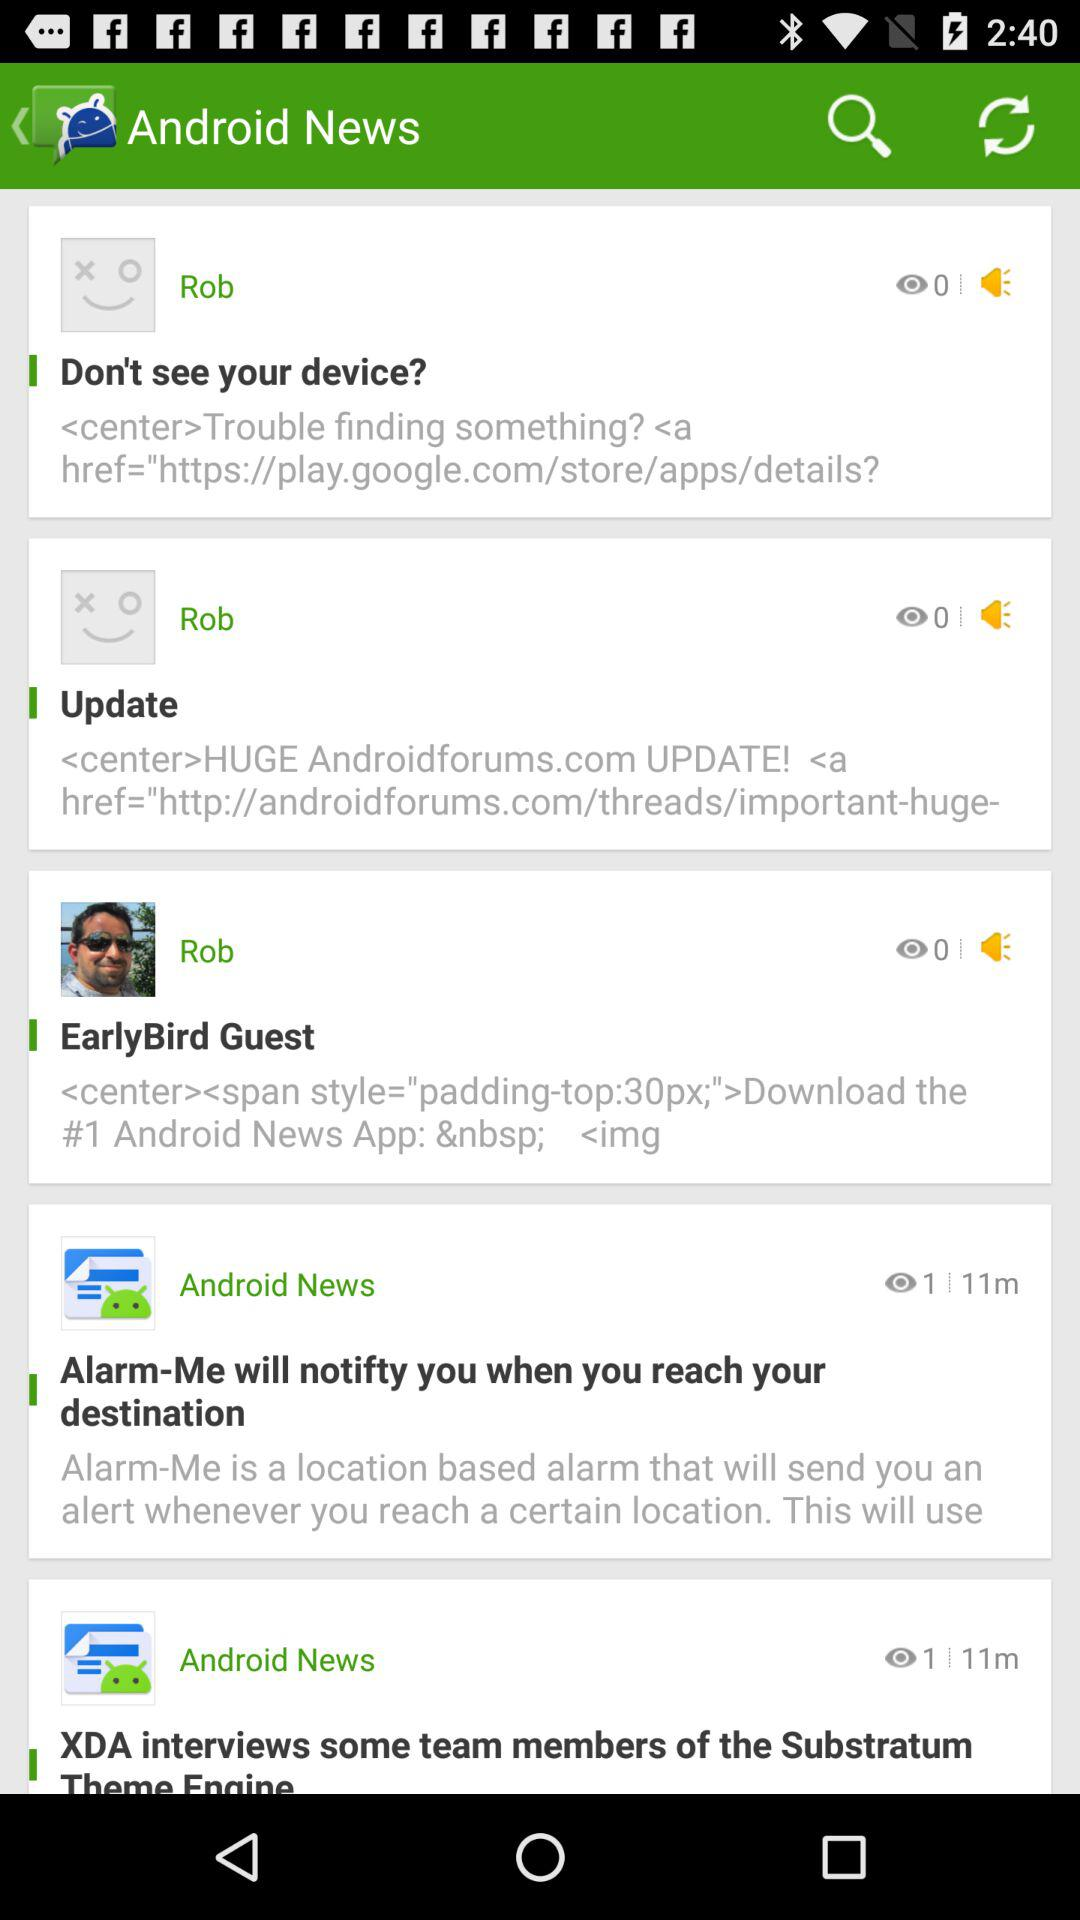What is the number of views of "Alarm-Me will notifty you when you reach your destination"? The number of views is 1. 